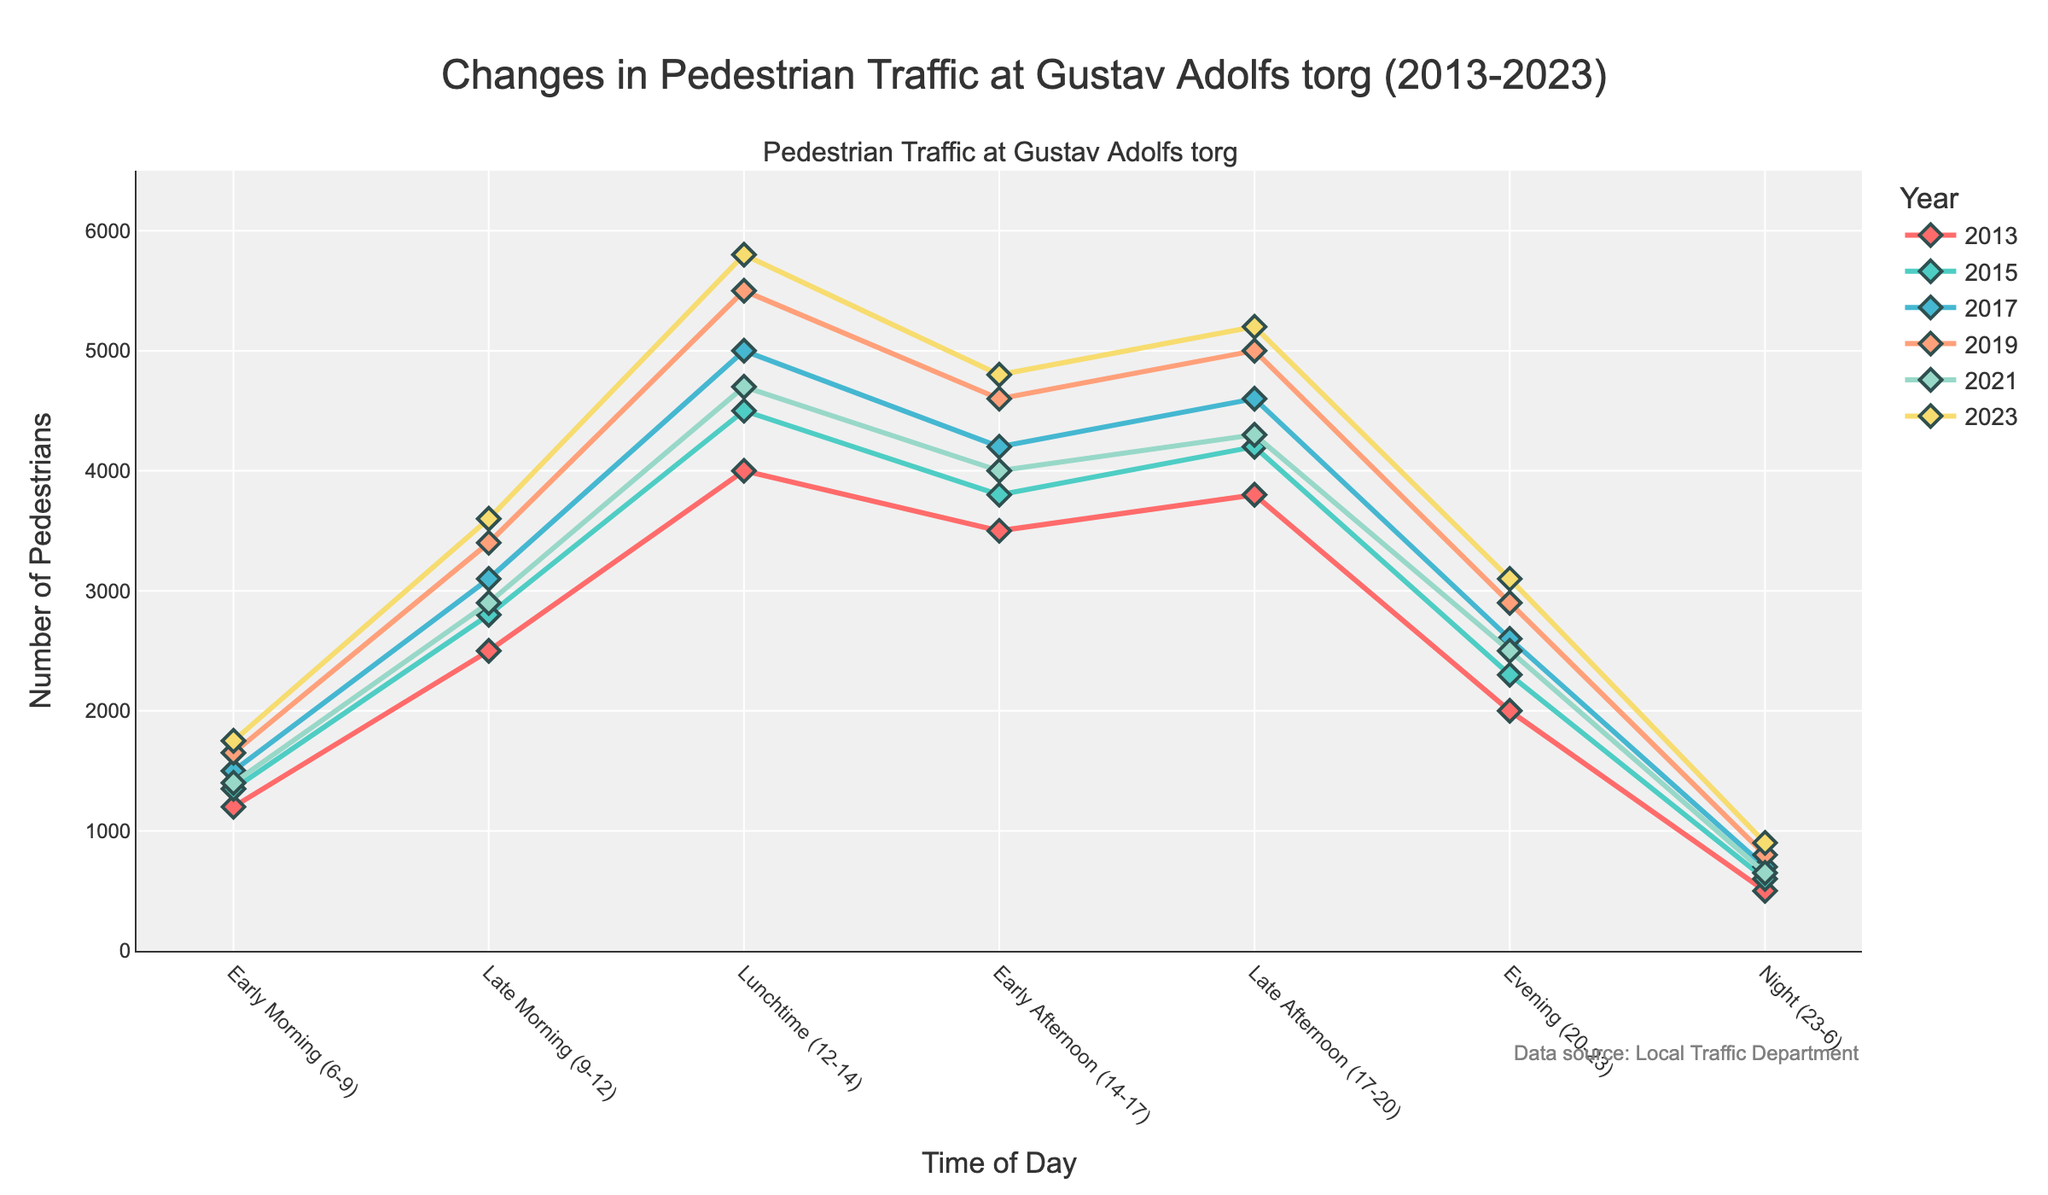What's the time of day with the highest pedestrian traffic in 2023? Look at the 2023 line and identify the peak value among the different times of day. The highest value is at "Lunchtime (12-14)" with 5800 pedestrians.
Answer: Lunchtime (12-14) How did the pedestrian traffic change from 2013 to 2023 during the Late Morning (9-12)? Subtract the number of pedestrians in 2013 from the number in 2023 during the Late Morning (9-12). The calculation is 3600 - 2500 = 1100.
Answer: Increased by 1100 Which time of day saw the largest increase in pedestrian traffic from 2019 to 2023? Calculate the difference for each time slot between 2019 and 2023, then identify the largest change. Early Morning: 1750-1650=100, Late Morning: 3600-3400=200, Lunchtime: 5800-5500=300, Early Afternoon: 4800-4600=200, Late Afternoon: 5200-5000=200, Evening: 3100-2900=200, Night: 900-800=100. Lunchtime shows the largest increase of 300.
Answer: Lunchtime (12-14) What is the average number of pedestrians in the Evening (20-23) across all years? Add the pedestrian counts for Evening (20-23) across all years and divide by the number of years. (2000 + 2300 + 2600 + 2900 + 2500 + 3100) / 6 = 2566.67.
Answer: 2566.67 During which time of day is the difference in pedestrian traffic between the years 2013 and 2017 the largest? Calculate the difference for each time slot between 2013 and 2017 and find the largest. Early Morning: 1500-1200=300, Late Morning: 3100-2500=600, Lunchtime: 5000-4000=1000, Early Afternoon: 4200-3500=700, Late Afternoon: 4600-3800=800, Evening: 2600-2000=600, Night: 700-500=200. Lunchtime shows the largest difference of 1000.
Answer: Lunchtime (12-14) What is the visual pattern of pedestrian traffic during the Early Morning (6-9) from 2013 to 2023? Describe the overall trend. The line starts at 1200 in 2013, increases slightly to 1350 in 2015, rises steadily to 1650 in 2019, drops to 1400 in 2021, and then peaks at 1750 in 2023.
Answer: Initial increase, slight drop, peak in 2023 Compare the pedestrian traffic in 2021 and 2023 during the Night (23-6). Directly compare the two years for the Night time slot. 2021: 650, 2023: 900.
Answer: 2023 had higher traffic by 250 Which time of day had the least pedestrian traffic in 2019? Identify the lowest value in the 2019 data. The Night (23-6) has the least traffic with 800 pedestrians.
Answer: Night (23-6) What's the trend in pedestrian traffic during Lunchtime (12-14) from 2013 to 2023? Describe the general pattern. The count starts at 4000 in 2013, rises consistently until it reaches 5500 in 2019, drops to 4700 in 2021, and then peaks at 5800 in 2023.
Answer: Generally increasing with a dip in 2021 